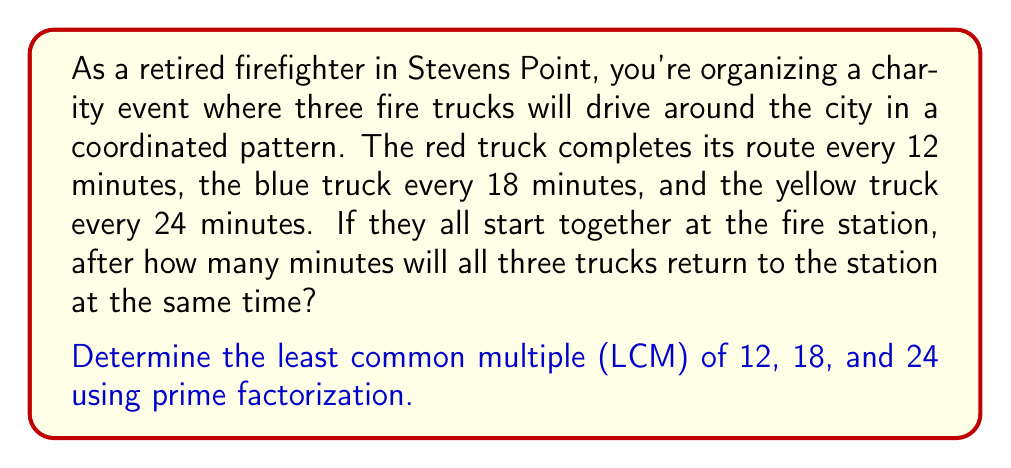Show me your answer to this math problem. To find the LCM of 12, 18, and 24 using prime factorization, we'll follow these steps:

1. Prime factorize each number:

   $12 = 2^2 \times 3$
   $18 = 2 \times 3^2$
   $24 = 2^3 \times 3$

2. Identify the highest power of each prime factor among all numbers:

   $2^3$ (from 24)
   $3^2$ (from 18)

3. Multiply these highest powers:

   $LCM = 2^3 \times 3^2$

4. Calculate the result:

   $LCM = 8 \times 9 = 72$

Therefore, the least common multiple of 12, 18, and 24 is 72 minutes.

This means that after 72 minutes, all three fire trucks will return to the station at the same time for the first time since the start of their routes.
Answer: $72$ minutes 